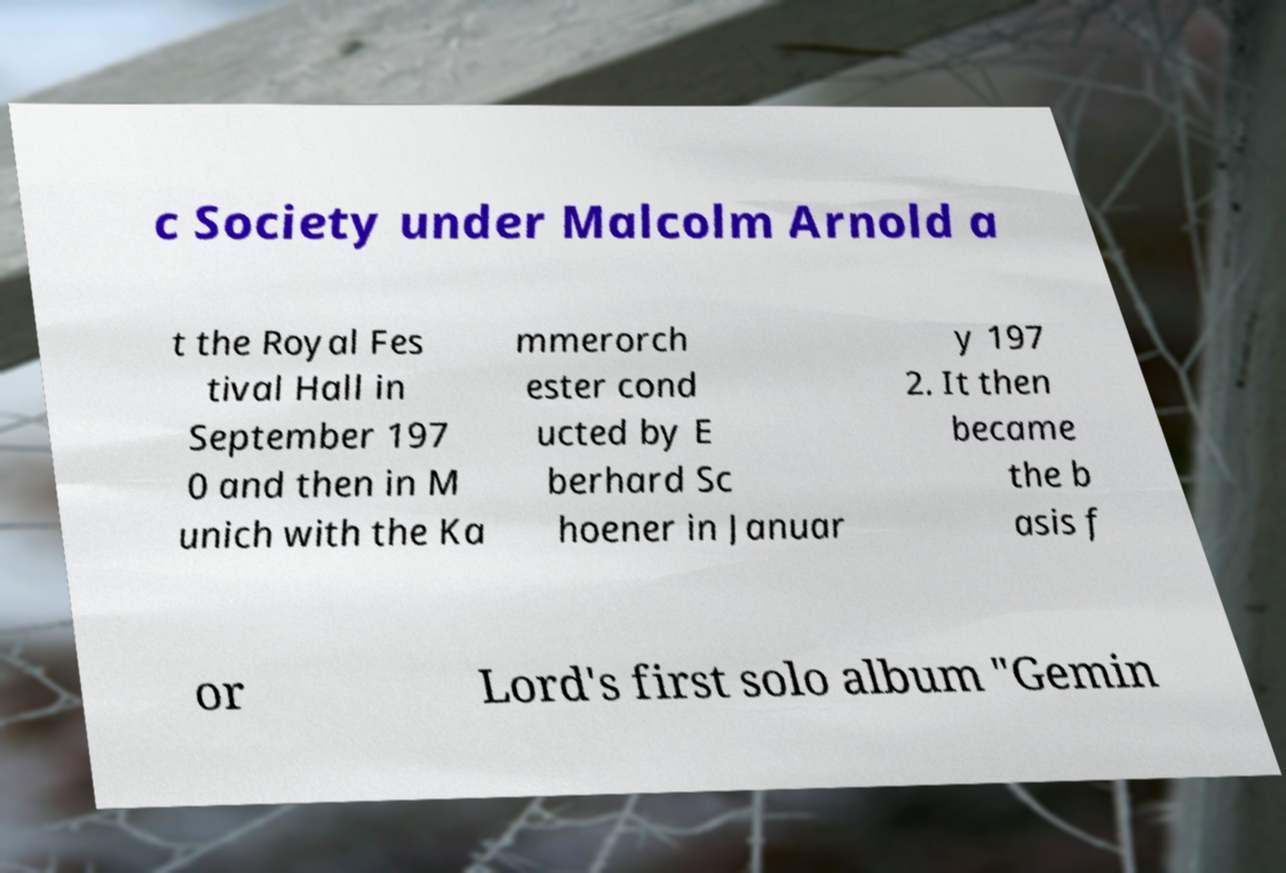Please read and relay the text visible in this image. What does it say? c Society under Malcolm Arnold a t the Royal Fes tival Hall in September 197 0 and then in M unich with the Ka mmerorch ester cond ucted by E berhard Sc hoener in Januar y 197 2. It then became the b asis f or Lord's first solo album "Gemin 